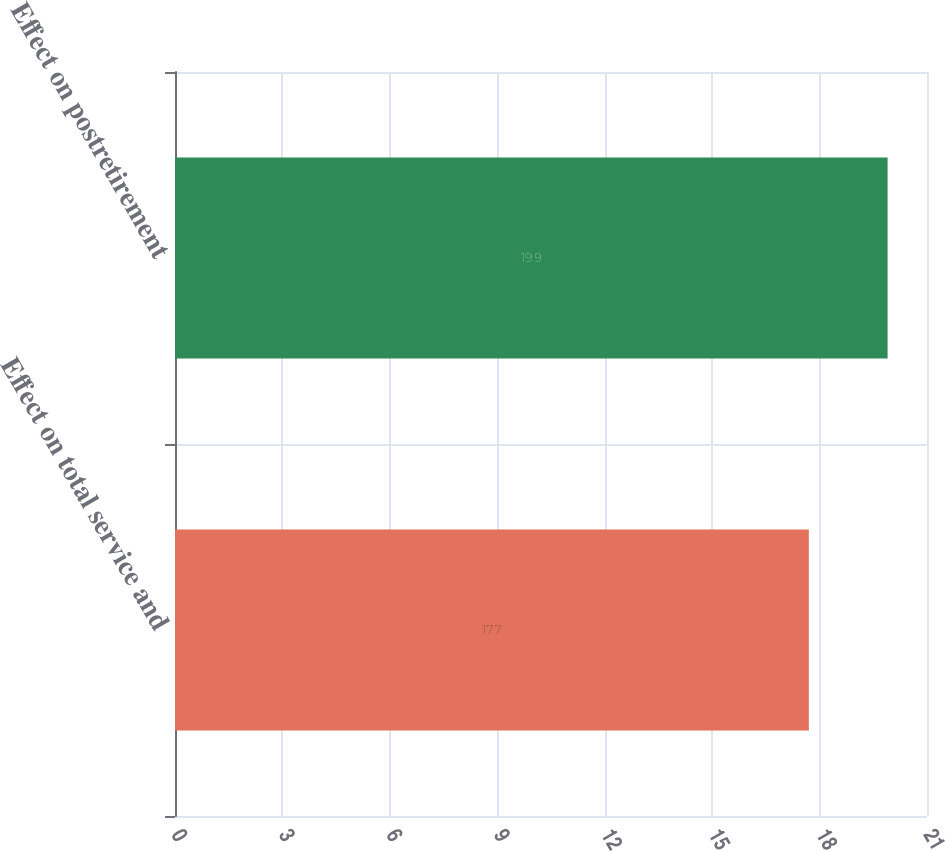Convert chart. <chart><loc_0><loc_0><loc_500><loc_500><bar_chart><fcel>Effect on total service and<fcel>Effect on postretirement<nl><fcel>17.7<fcel>19.9<nl></chart> 